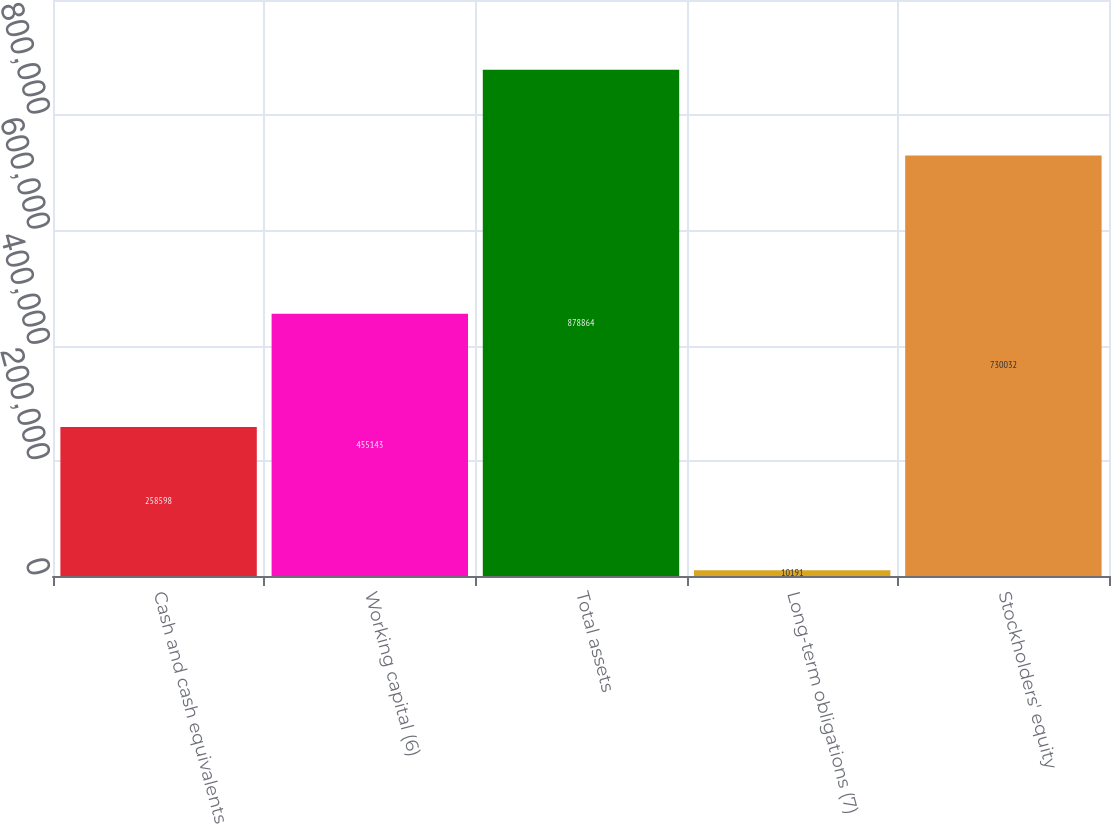Convert chart to OTSL. <chart><loc_0><loc_0><loc_500><loc_500><bar_chart><fcel>Cash and cash equivalents<fcel>Working capital (6)<fcel>Total assets<fcel>Long-term obligations (7)<fcel>Stockholders' equity<nl><fcel>258598<fcel>455143<fcel>878864<fcel>10191<fcel>730032<nl></chart> 